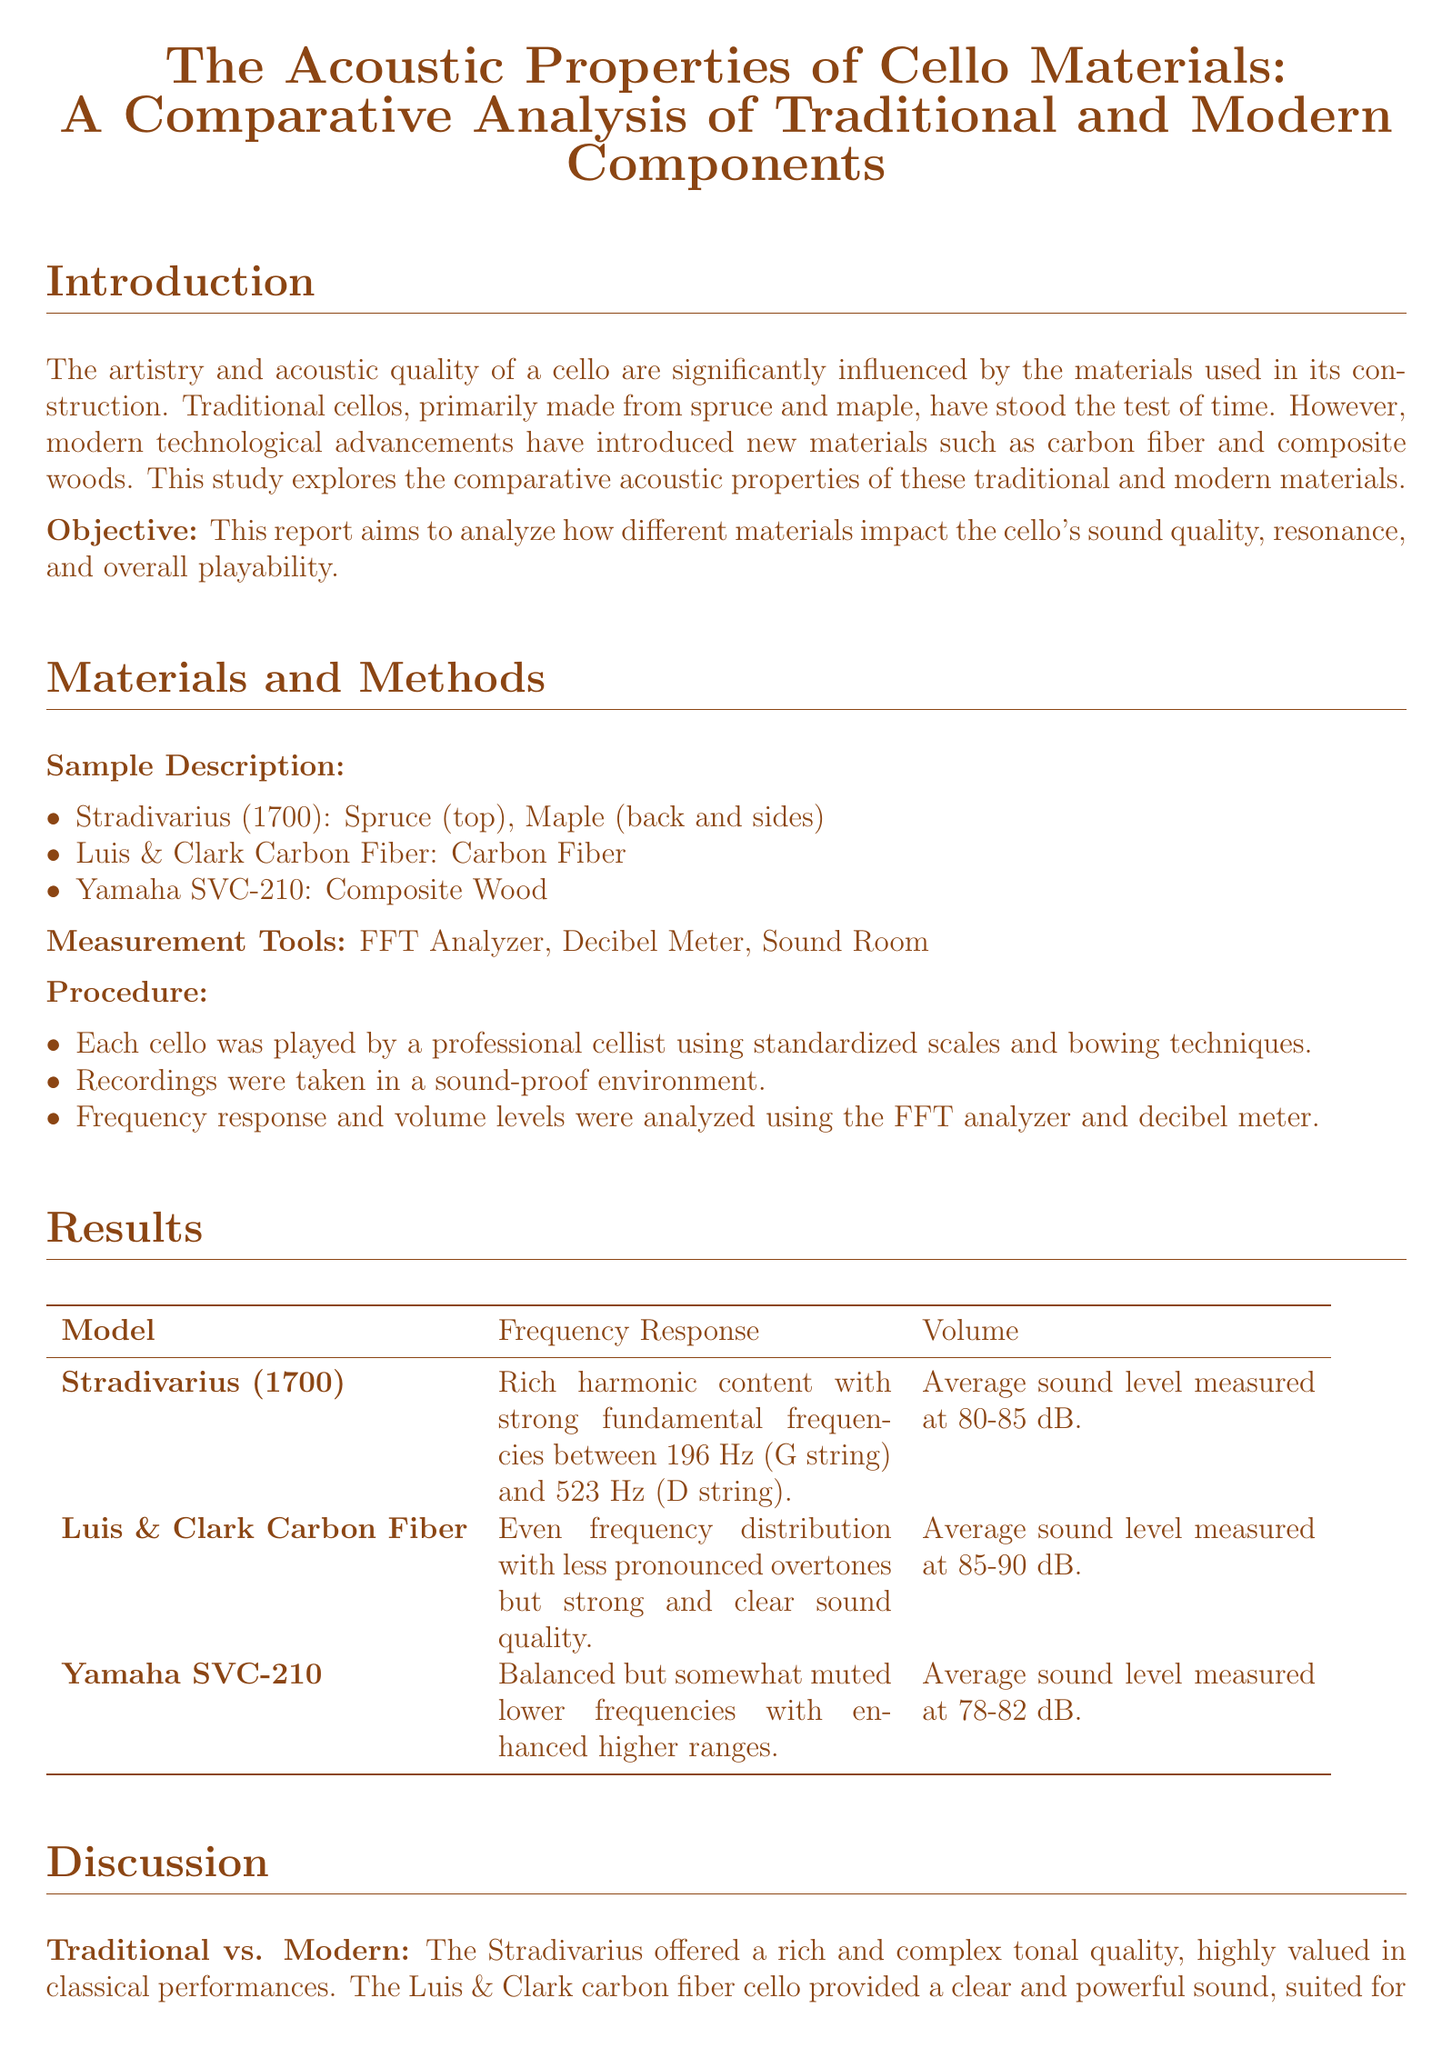What materials are used in the Stradivarius cello? The Stradivarius cello is made from spruce (top) and maple (back and sides).
Answer: spruce and maple What was the average sound level of the Luis & Clark Carbon Fiber cello? The average sound level measured for the Luis & Clark Carbon Fiber cello is 85-90 dB.
Answer: 85-90 dB Which cello model showed balanced but somewhat muted lower frequencies? The Yamaha SVC-210 showed balanced but somewhat muted lower frequencies.
Answer: Yamaha SVC-210 What is the primary objective of the lab report? The primary objective of the lab report is to analyze how different materials impact the cello's sound quality, resonance, and overall playability.
Answer: Analyze impact on sound quality Which cello provided a clear and powerful sound? The Luis & Clark Carbon Fiber cello provided a clear and powerful sound.
Answer: Luis & Clark Carbon Fiber What advantage do carbon fiber cellos have over traditional wooden cellos? Carbon fiber cellos have enhanced durability and resistance to environmental changes.
Answer: Durability and resistance What year was the Stradivarius cello created? The Stradivarius cello was created in 1700.
Answer: 1700 What need is identified for future research? Future research could involve a larger sample size and more diverse playing styles.
Answer: Larger sample size and diverse styles 